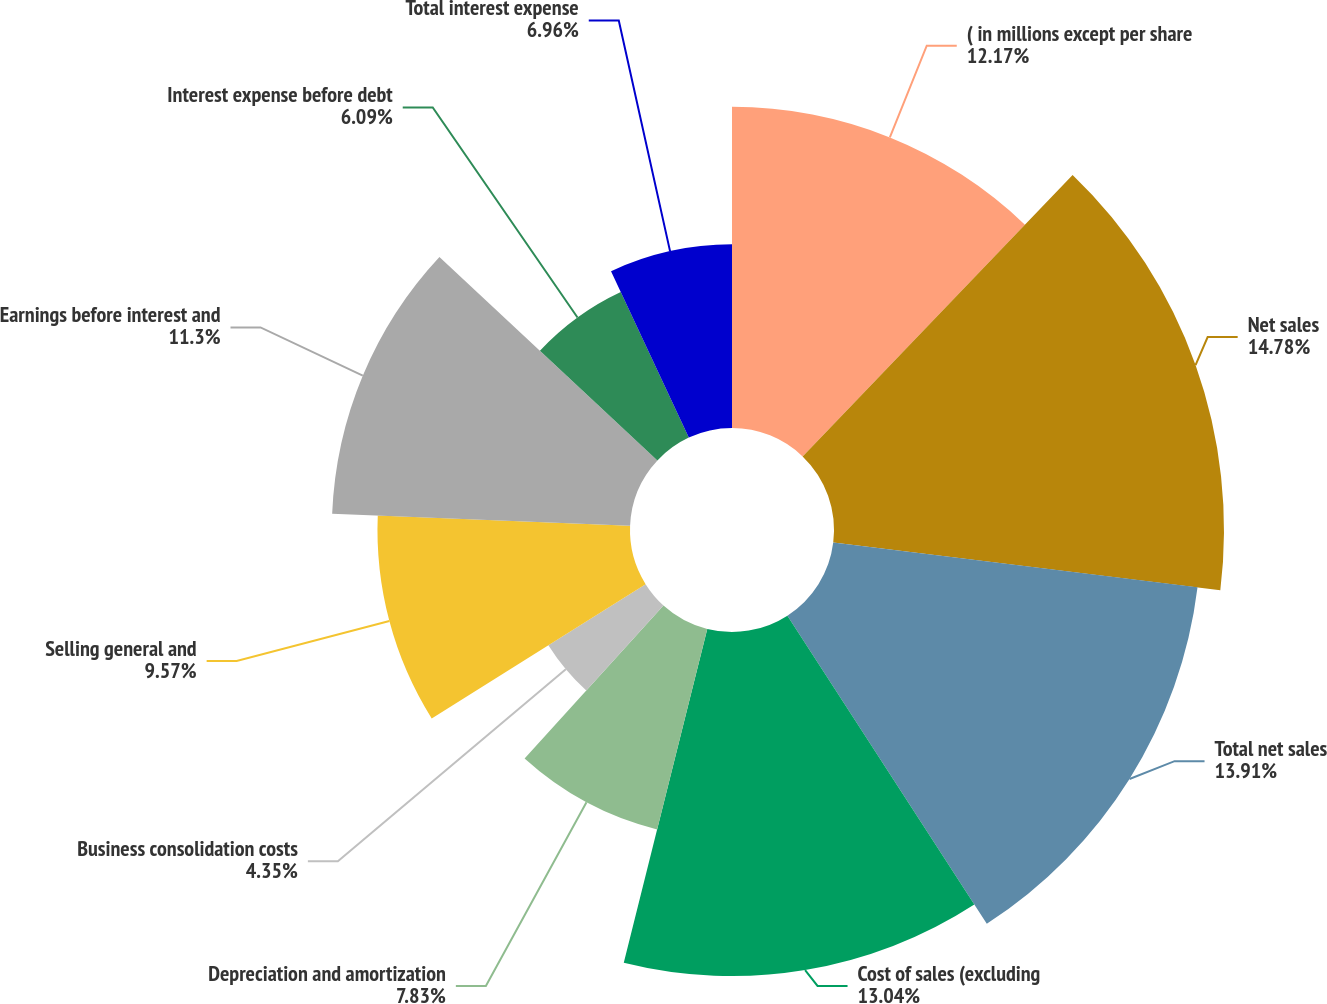Convert chart to OTSL. <chart><loc_0><loc_0><loc_500><loc_500><pie_chart><fcel>( in millions except per share<fcel>Net sales<fcel>Total net sales<fcel>Cost of sales (excluding<fcel>Depreciation and amortization<fcel>Business consolidation costs<fcel>Selling general and<fcel>Earnings before interest and<fcel>Interest expense before debt<fcel>Total interest expense<nl><fcel>12.17%<fcel>14.78%<fcel>13.91%<fcel>13.04%<fcel>7.83%<fcel>4.35%<fcel>9.57%<fcel>11.3%<fcel>6.09%<fcel>6.96%<nl></chart> 